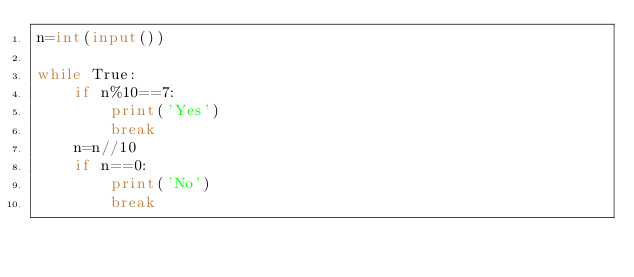Convert code to text. <code><loc_0><loc_0><loc_500><loc_500><_Python_>n=int(input())

while True:
    if n%10==7:
        print('Yes')
        break
    n=n//10
    if n==0:
        print('No')
        break
        </code> 